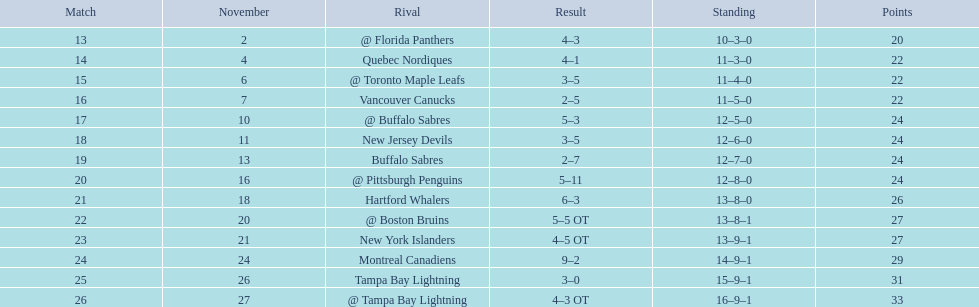Which was the only team in the atlantic division in the 1993-1994 season to acquire less points than the philadelphia flyers? Tampa Bay Lightning. 